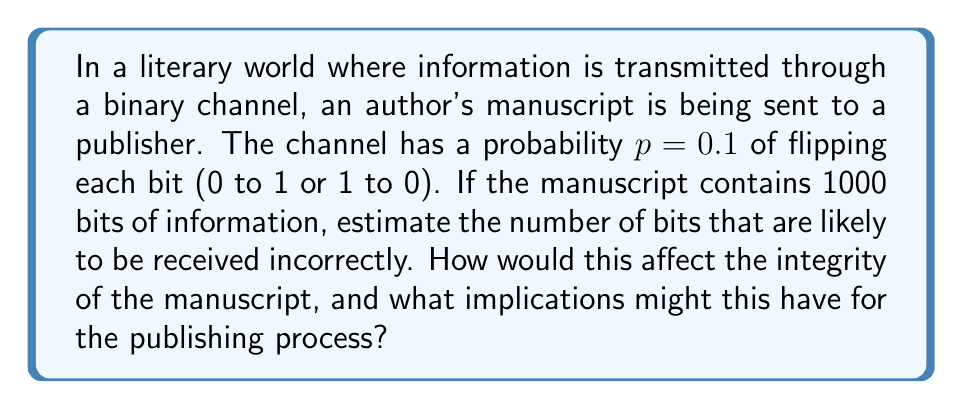What is the answer to this math problem? To solve this problem, we need to understand the concept of a binary symmetric channel (BSC) and apply probability theory. Let's break it down step-by-step:

1) In a BSC, each bit has an independent probability $p$ of being flipped. In this case, $p = 0.1$.

2) The probability of a bit being received correctly is $1 - p = 0.9$.

3) For each bit, we can consider this as a Bernoulli trial, where "success" is an error occurring (with probability $p$), and "failure" is the bit being transmitted correctly (with probability $1-p$).

4) With 1000 bits being transmitted, we have 1000 independent Bernoulli trials. This scenario follows a binomial distribution.

5) The expected number of errors in a binomial distribution is given by the formula:

   $$E(X) = np$$

   Where $n$ is the number of trials and $p$ is the probability of success (error in this case).

6) Plugging in our values:

   $$E(X) = 1000 * 0.1 = 100$$

Therefore, we expect about 100 bits to be received incorrectly.

Regarding the implications for the publishing process:
- 100 errors in 1000 bits is a significant error rate (10%), which could severely distort the manuscript's content.
- This could lead to misinterpretations, changed meanings, or nonsensical passages.
- The publisher would likely need to implement error-detection and correction mechanisms, or request multiple transmissions to cross-verify the content.
- This situation highlights the importance of reliable communication channels in the publishing industry, especially when dealing with digital manuscripts.
Answer: The expected number of incorrectly received bits is 100. This high error rate could significantly impact the manuscript's integrity and complicate the publishing process, necessitating additional error-checking measures. 